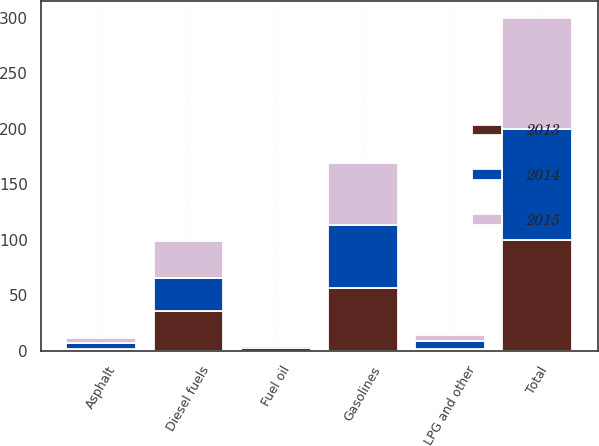Convert chart. <chart><loc_0><loc_0><loc_500><loc_500><stacked_bar_chart><ecel><fcel>Gasolines<fcel>Diesel fuels<fcel>Fuel oil<fcel>Asphalt<fcel>LPG and other<fcel>Total<nl><fcel>2013<fcel>57<fcel>36<fcel>3<fcel>2<fcel>2<fcel>100<nl><fcel>2015<fcel>56<fcel>33<fcel>1<fcel>5<fcel>5<fcel>100<nl><fcel>2014<fcel>56<fcel>30<fcel>1<fcel>5<fcel>7<fcel>100<nl></chart> 